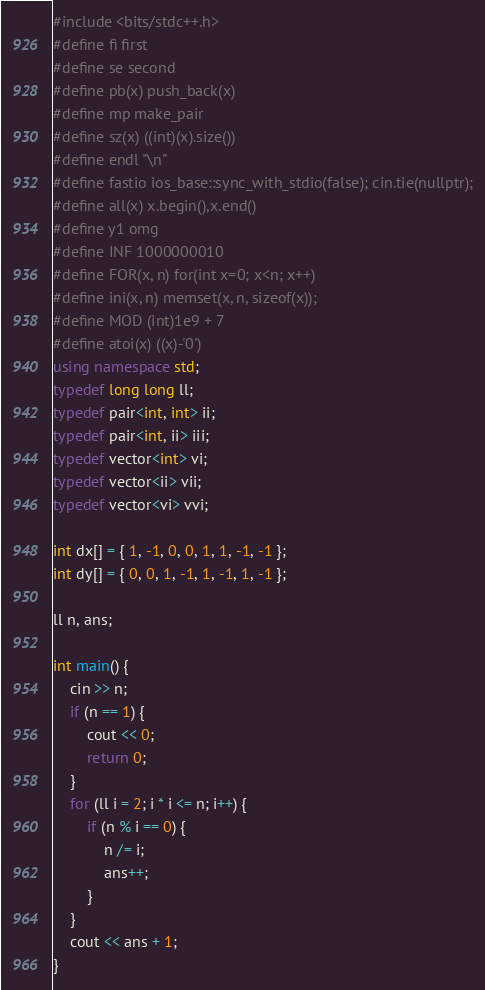<code> <loc_0><loc_0><loc_500><loc_500><_C++_>#include <bits/stdc++.h>
#define fi first
#define se second
#define pb(x) push_back(x)
#define mp make_pair
#define sz(x) ((int)(x).size())
#define endl "\n"
#define fastio ios_base::sync_with_stdio(false); cin.tie(nullptr);
#define all(x) x.begin(),x.end()
#define y1 omg
#define INF 1000000010
#define FOR(x, n) for(int x=0; x<n; x++)
#define ini(x, n) memset(x, n, sizeof(x));
#define MOD (int)1e9 + 7
#define atoi(x) ((x)-'0')
using namespace std;
typedef long long ll;
typedef pair<int, int> ii;
typedef pair<int, ii> iii;
typedef vector<int> vi;
typedef vector<ii> vii;
typedef vector<vi> vvi;

int dx[] = { 1, -1, 0, 0, 1, 1, -1, -1 };
int dy[] = { 0, 0, 1, -1, 1, -1, 1, -1 };

ll n, ans;

int main() {
	cin >> n;
	if (n == 1) {
		cout << 0;
		return 0;
	}
	for (ll i = 2; i * i <= n; i++) {
		if (n % i == 0) {
			n /= i;
			ans++;
		}
	}
	cout << ans + 1;
}</code> 